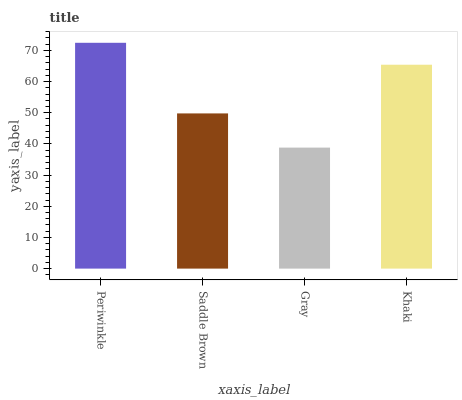Is Gray the minimum?
Answer yes or no. Yes. Is Periwinkle the maximum?
Answer yes or no. Yes. Is Saddle Brown the minimum?
Answer yes or no. No. Is Saddle Brown the maximum?
Answer yes or no. No. Is Periwinkle greater than Saddle Brown?
Answer yes or no. Yes. Is Saddle Brown less than Periwinkle?
Answer yes or no. Yes. Is Saddle Brown greater than Periwinkle?
Answer yes or no. No. Is Periwinkle less than Saddle Brown?
Answer yes or no. No. Is Khaki the high median?
Answer yes or no. Yes. Is Saddle Brown the low median?
Answer yes or no. Yes. Is Gray the high median?
Answer yes or no. No. Is Gray the low median?
Answer yes or no. No. 